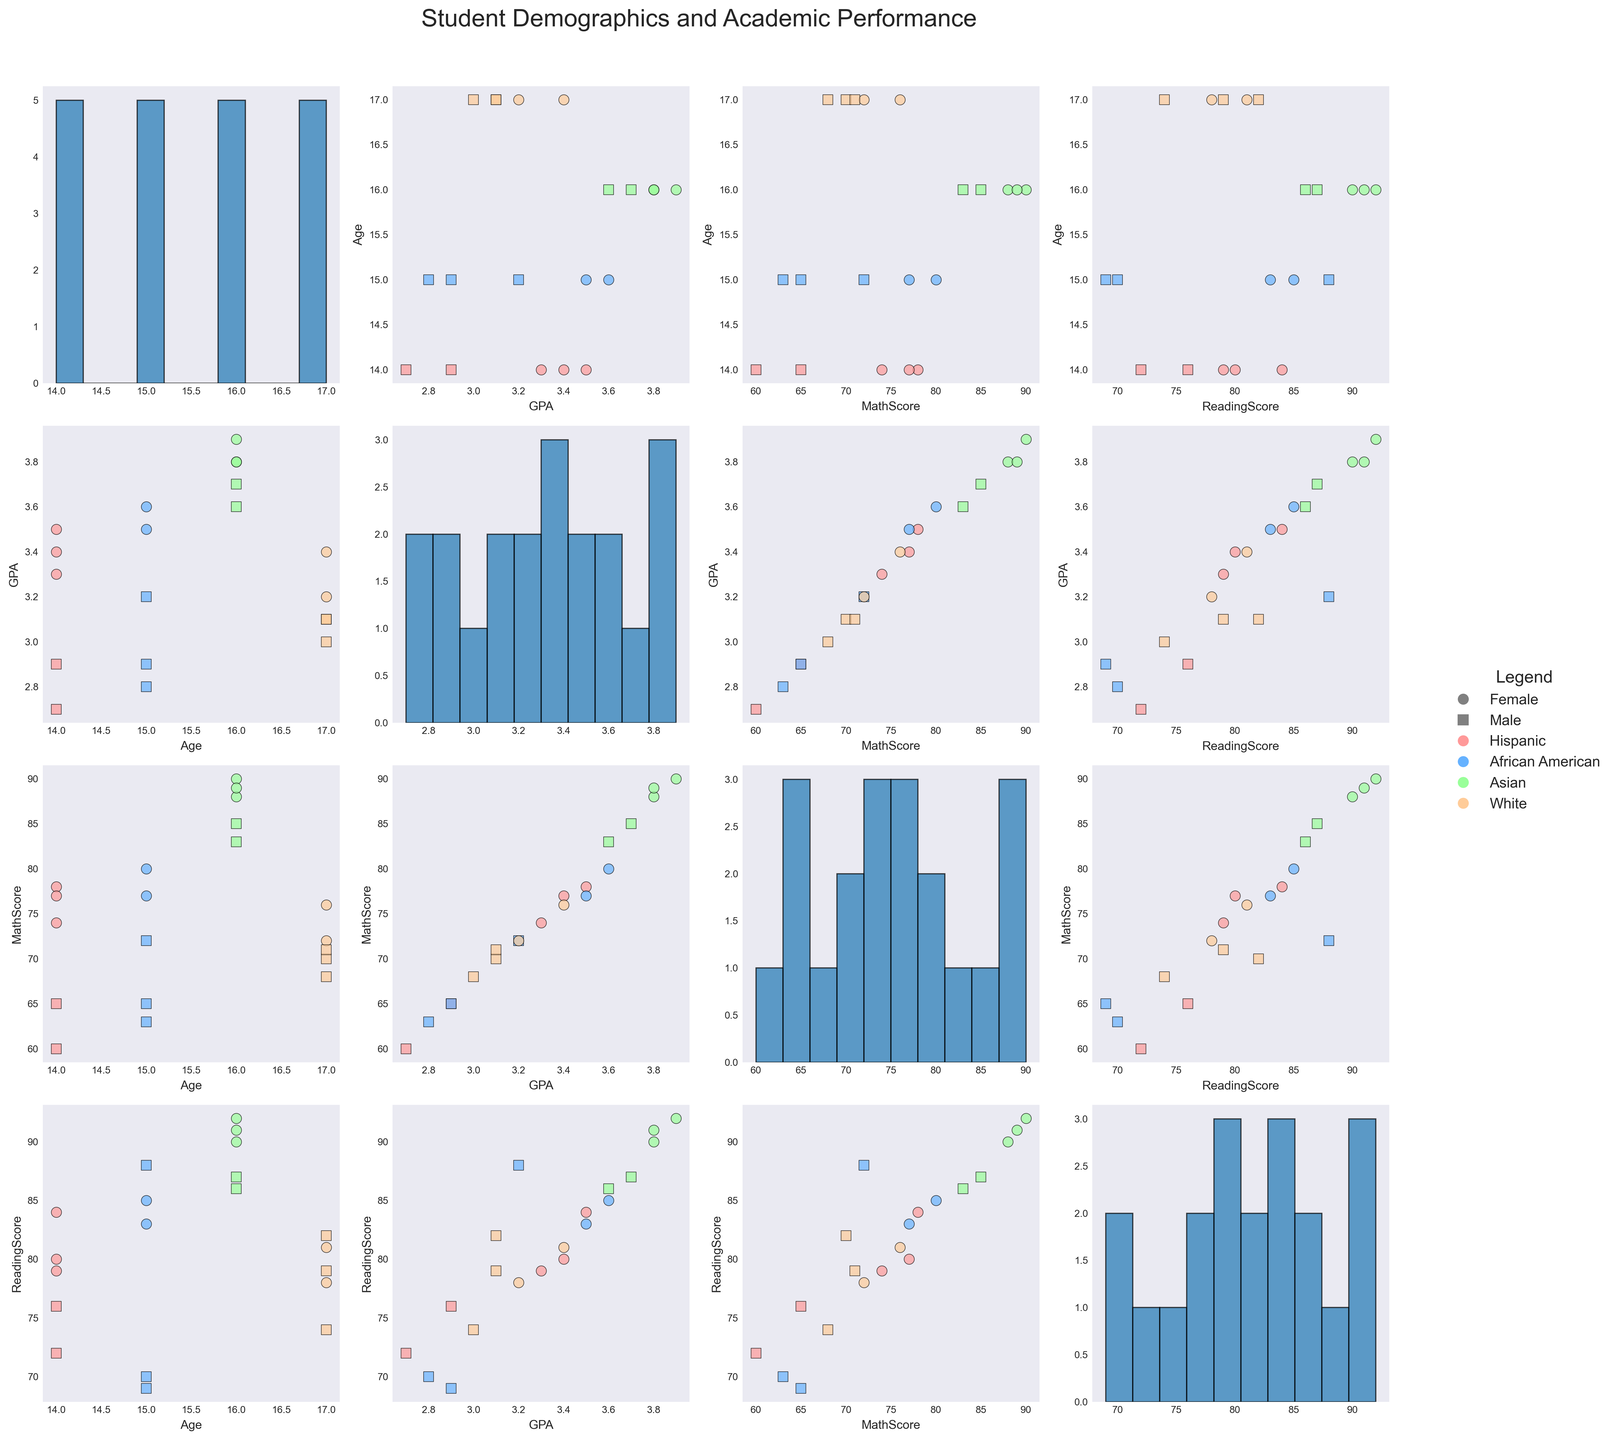How many ethnic groups are represented in the scatter plot matrix? The scatter plot matrix uses different colors to represent ethnic groups. There are four distinct colors in the legend corresponding to four ethnic groups: Hispanic, African American, Asian, and White.
Answer: 4 Which gender has more students within the age group of 15 based on the scatter plot matrix? The scatter plots with Age on the x-axis for Age = 15 show that both female and male students are represented. To determine which gender has more students, we count the markers. There are 2 females and 2 males at age 15.
Answer: Equal In the scatter plot for Age vs. GPA, which ethnic group has the highest GPA? In the scatter plot where Age is plotted against GPA, we identify the highest points for GPA. The highest GPA values are represented by the green points, which correspond to the Asian ethnic group.
Answer: Asian What is the average MathScore for Hispanic students? Look at the MathScore axis and locate the points for Hispanic students (marked in red). The MathScore values for Hispanic students are 78, 65, 74, 60, and 77. The average is calculated as (78 + 65 + 74 + 60 + 77) / 5 = 70.8.
Answer: 70.8 Comparing males and females, which gender generally scores higher in ReadingScore? We need to look at the scatterplots having ReadingScore on one axis and compare the scores based on markers. Females have a higher concentration of upper scores (represented by circles) compared to males (represented by squares).
Answer: Female In the scatter plot matrix, what trend can be observed between MathScore and GPA? Visual examination of the scatterplots with MathScore on one axis and GPA on the other show a general positive trend; students with higher MathScores tend to have higher GPAs.
Answer: Positive correlation Among the scatter plots that include gender, who has the highest MathScore within the African American group? Find the MathScore axis plots and look for African American markers (blue) and different shapes for gender. The highest MathScore for African American students is 80, and it is marked by a circle (female).
Answer: Female Across all age groups, which ethnic group tends to score the highest in ReadingScore? Look at the scatterplots that include ReadingScore and identify the ethnic group color with consistently high ReadingScores. The green points (Asian) are often at the top of the axis, indicating they tend to score the highest in ReadingScore.
Answer: Asian 